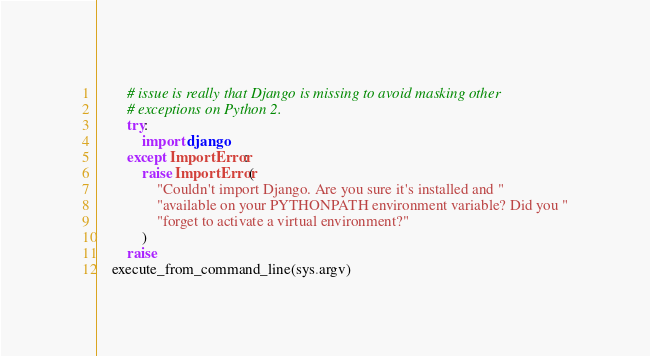<code> <loc_0><loc_0><loc_500><loc_500><_Python_>        # issue is really that Django is missing to avoid masking other
        # exceptions on Python 2.
        try:
            import django
        except ImportError:
            raise ImportError(
                "Couldn't import Django. Are you sure it's installed and "
                "available on your PYTHONPATH environment variable? Did you "
                "forget to activate a virtual environment?"
            )
        raise
    execute_from_command_line(sys.argv)
</code> 